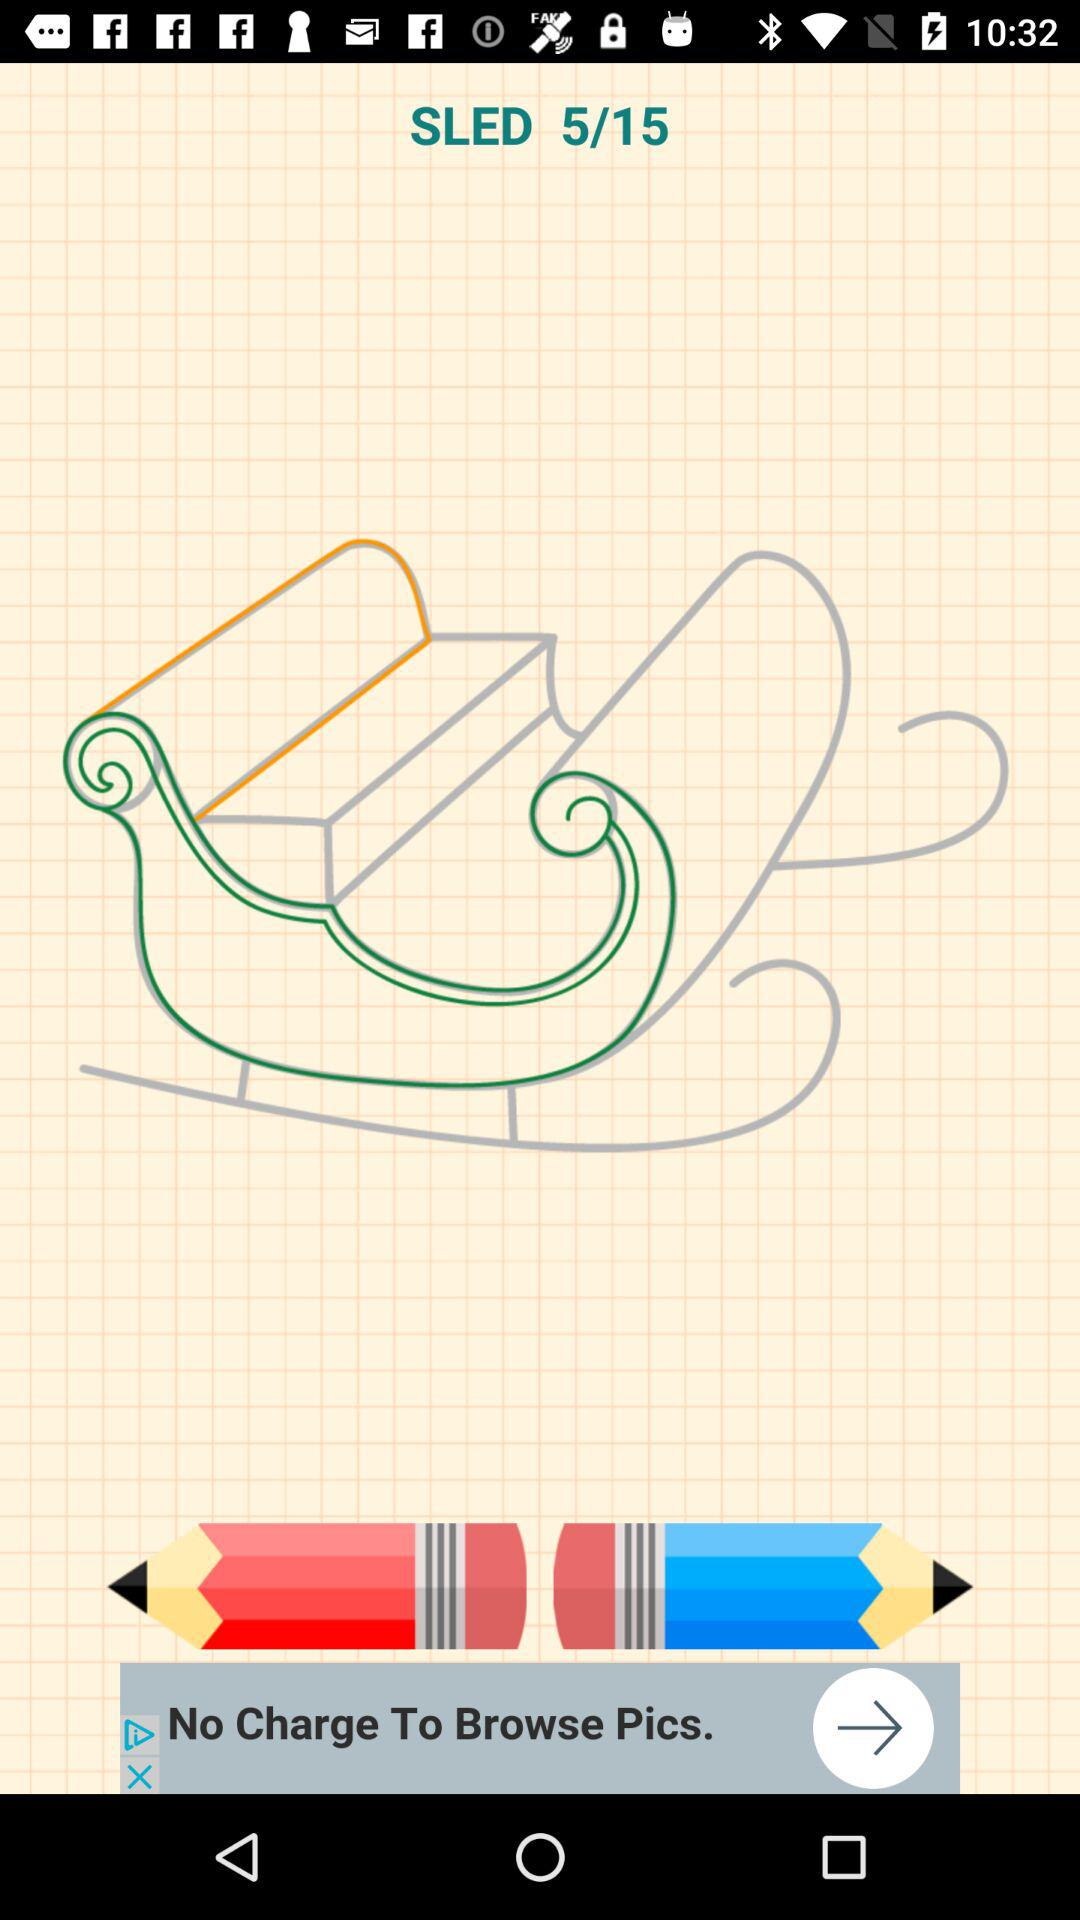I am on what page? The page is 5. 